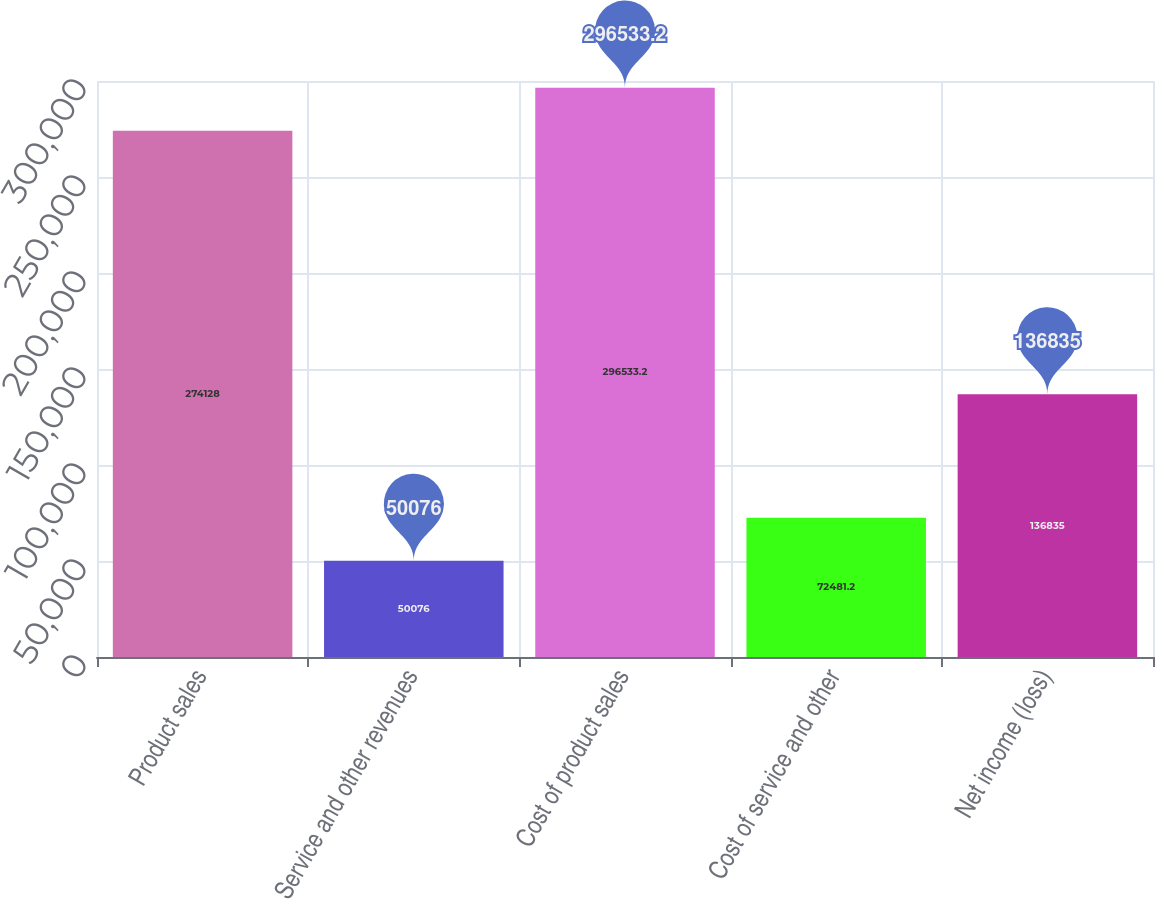Convert chart. <chart><loc_0><loc_0><loc_500><loc_500><bar_chart><fcel>Product sales<fcel>Service and other revenues<fcel>Cost of product sales<fcel>Cost of service and other<fcel>Net income (loss)<nl><fcel>274128<fcel>50076<fcel>296533<fcel>72481.2<fcel>136835<nl></chart> 